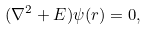Convert formula to latex. <formula><loc_0><loc_0><loc_500><loc_500>( \nabla ^ { 2 } + E ) \psi ( { r } ) = 0 ,</formula> 